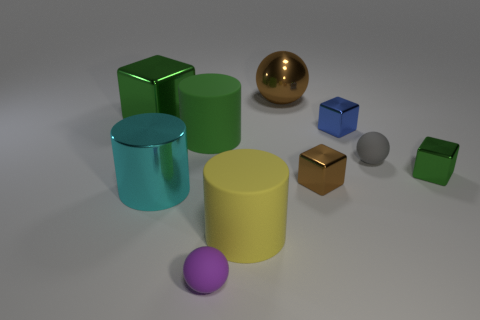Can you infer anything about the light source in this scene? The shadows and the reflections on the objects suggest there's a single light source positioned above and to the right of the scene. The light source is likely diffused, as the shadows have soft edges, which normally occurs when the light is scattered through a larger area. 